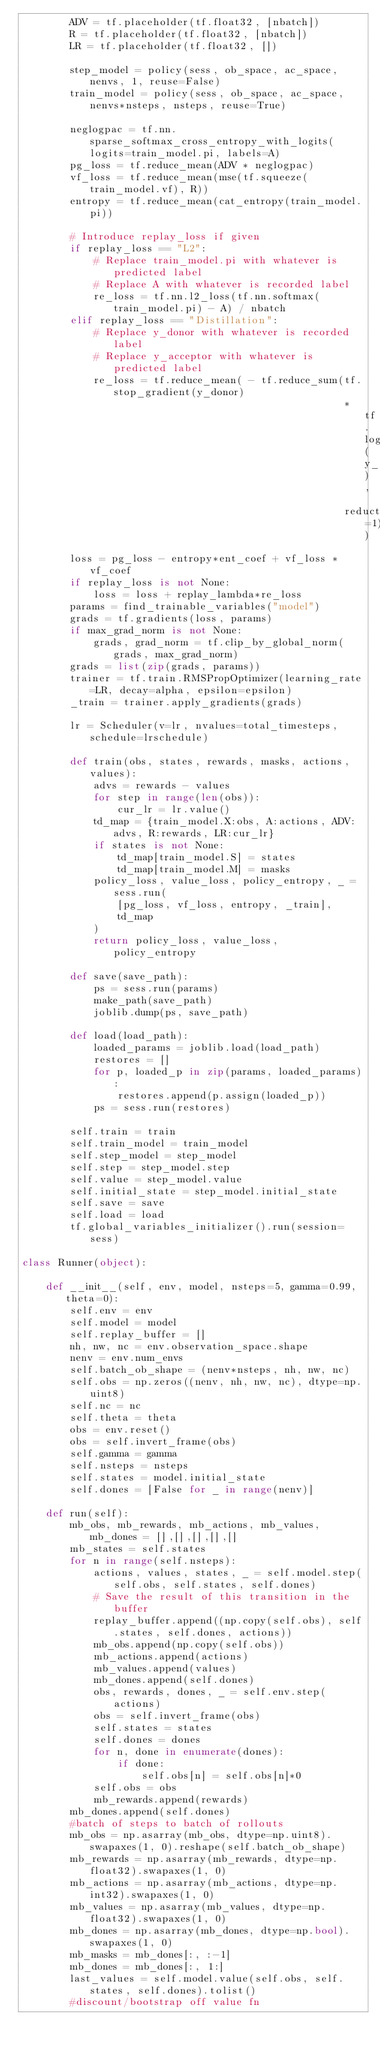<code> <loc_0><loc_0><loc_500><loc_500><_Python_>        ADV = tf.placeholder(tf.float32, [nbatch])
        R = tf.placeholder(tf.float32, [nbatch])
        LR = tf.placeholder(tf.float32, [])

        step_model = policy(sess, ob_space, ac_space, nenvs, 1, reuse=False)
        train_model = policy(sess, ob_space, ac_space, nenvs*nsteps, nsteps, reuse=True)

        neglogpac = tf.nn.sparse_softmax_cross_entropy_with_logits(logits=train_model.pi, labels=A)
        pg_loss = tf.reduce_mean(ADV * neglogpac)
        vf_loss = tf.reduce_mean(mse(tf.squeeze(train_model.vf), R))
        entropy = tf.reduce_mean(cat_entropy(train_model.pi))

        # Introduce replay_loss if given
        if replay_loss == "L2":
            # Replace train_model.pi with whatever is predicted label
            # Replace A with whatever is recorded label
            re_loss = tf.nn.l2_loss(tf.nn.softmax(train_model.pi) - A) / nbatch
        elif replay_loss == "Distillation":
            # Replace y_donor with whatever is recorded label
            # Replace y_acceptor with whatever is predicted label
            re_loss = tf.reduce_mean( - tf.reduce_sum(tf.stop_gradient(y_donor)
                                                      * tf.log(y_acceptor),
                                                      reduction_indices=1))
        loss = pg_loss - entropy*ent_coef + vf_loss * vf_coef
        if replay_loss is not None:
            loss = loss + replay_lambda*re_loss
        params = find_trainable_variables("model")
        grads = tf.gradients(loss, params)
        if max_grad_norm is not None:
            grads, grad_norm = tf.clip_by_global_norm(grads, max_grad_norm)
        grads = list(zip(grads, params))
        trainer = tf.train.RMSPropOptimizer(learning_rate=LR, decay=alpha, epsilon=epsilon)
        _train = trainer.apply_gradients(grads)

        lr = Scheduler(v=lr, nvalues=total_timesteps, schedule=lrschedule)

        def train(obs, states, rewards, masks, actions, values):
            advs = rewards - values
            for step in range(len(obs)):
                cur_lr = lr.value()
            td_map = {train_model.X:obs, A:actions, ADV:advs, R:rewards, LR:cur_lr}
            if states is not None:
                td_map[train_model.S] = states
                td_map[train_model.M] = masks
            policy_loss, value_loss, policy_entropy, _ = sess.run(
                [pg_loss, vf_loss, entropy, _train],
                td_map
            )
            return policy_loss, value_loss, policy_entropy

        def save(save_path):
            ps = sess.run(params)
            make_path(save_path)
            joblib.dump(ps, save_path)

        def load(load_path):
            loaded_params = joblib.load(load_path)
            restores = []
            for p, loaded_p in zip(params, loaded_params):
                restores.append(p.assign(loaded_p))
            ps = sess.run(restores)

        self.train = train
        self.train_model = train_model
        self.step_model = step_model
        self.step = step_model.step
        self.value = step_model.value
        self.initial_state = step_model.initial_state
        self.save = save
        self.load = load
        tf.global_variables_initializer().run(session=sess)

class Runner(object):

    def __init__(self, env, model, nsteps=5, gamma=0.99, theta=0):
        self.env = env
        self.model = model
        self.replay_buffer = []
        nh, nw, nc = env.observation_space.shape
        nenv = env.num_envs
        self.batch_ob_shape = (nenv*nsteps, nh, nw, nc)
        self.obs = np.zeros((nenv, nh, nw, nc), dtype=np.uint8)
        self.nc = nc
        self.theta = theta
        obs = env.reset()
        obs = self.invert_frame(obs)
        self.gamma = gamma
        self.nsteps = nsteps
        self.states = model.initial_state
        self.dones = [False for _ in range(nenv)]

    def run(self):
        mb_obs, mb_rewards, mb_actions, mb_values, mb_dones = [],[],[],[],[]
        mb_states = self.states
        for n in range(self.nsteps):
            actions, values, states, _ = self.model.step(self.obs, self.states, self.dones)
            # Save the result of this transition in the buffer
            replay_buffer.append((np.copy(self.obs), self.states, self.dones, actions))
            mb_obs.append(np.copy(self.obs))
            mb_actions.append(actions)
            mb_values.append(values)
            mb_dones.append(self.dones)
            obs, rewards, dones, _ = self.env.step(actions)
            obs = self.invert_frame(obs)
            self.states = states
            self.dones = dones
            for n, done in enumerate(dones):
                if done:
                    self.obs[n] = self.obs[n]*0
            self.obs = obs
            mb_rewards.append(rewards)
        mb_dones.append(self.dones)
        #batch of steps to batch of rollouts
        mb_obs = np.asarray(mb_obs, dtype=np.uint8).swapaxes(1, 0).reshape(self.batch_ob_shape)
        mb_rewards = np.asarray(mb_rewards, dtype=np.float32).swapaxes(1, 0)
        mb_actions = np.asarray(mb_actions, dtype=np.int32).swapaxes(1, 0)
        mb_values = np.asarray(mb_values, dtype=np.float32).swapaxes(1, 0)
        mb_dones = np.asarray(mb_dones, dtype=np.bool).swapaxes(1, 0)
        mb_masks = mb_dones[:, :-1]
        mb_dones = mb_dones[:, 1:]
        last_values = self.model.value(self.obs, self.states, self.dones).tolist()
        #discount/bootstrap off value fn</code> 